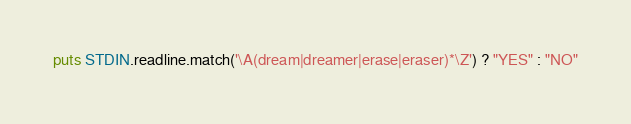<code> <loc_0><loc_0><loc_500><loc_500><_Ruby_>puts STDIN.readline.match('\A(dream|dreamer|erase|eraser)*\Z') ? "YES" : "NO"</code> 